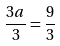<formula> <loc_0><loc_0><loc_500><loc_500>\frac { 3 a } { 3 } = \frac { 9 } { 3 }</formula> 